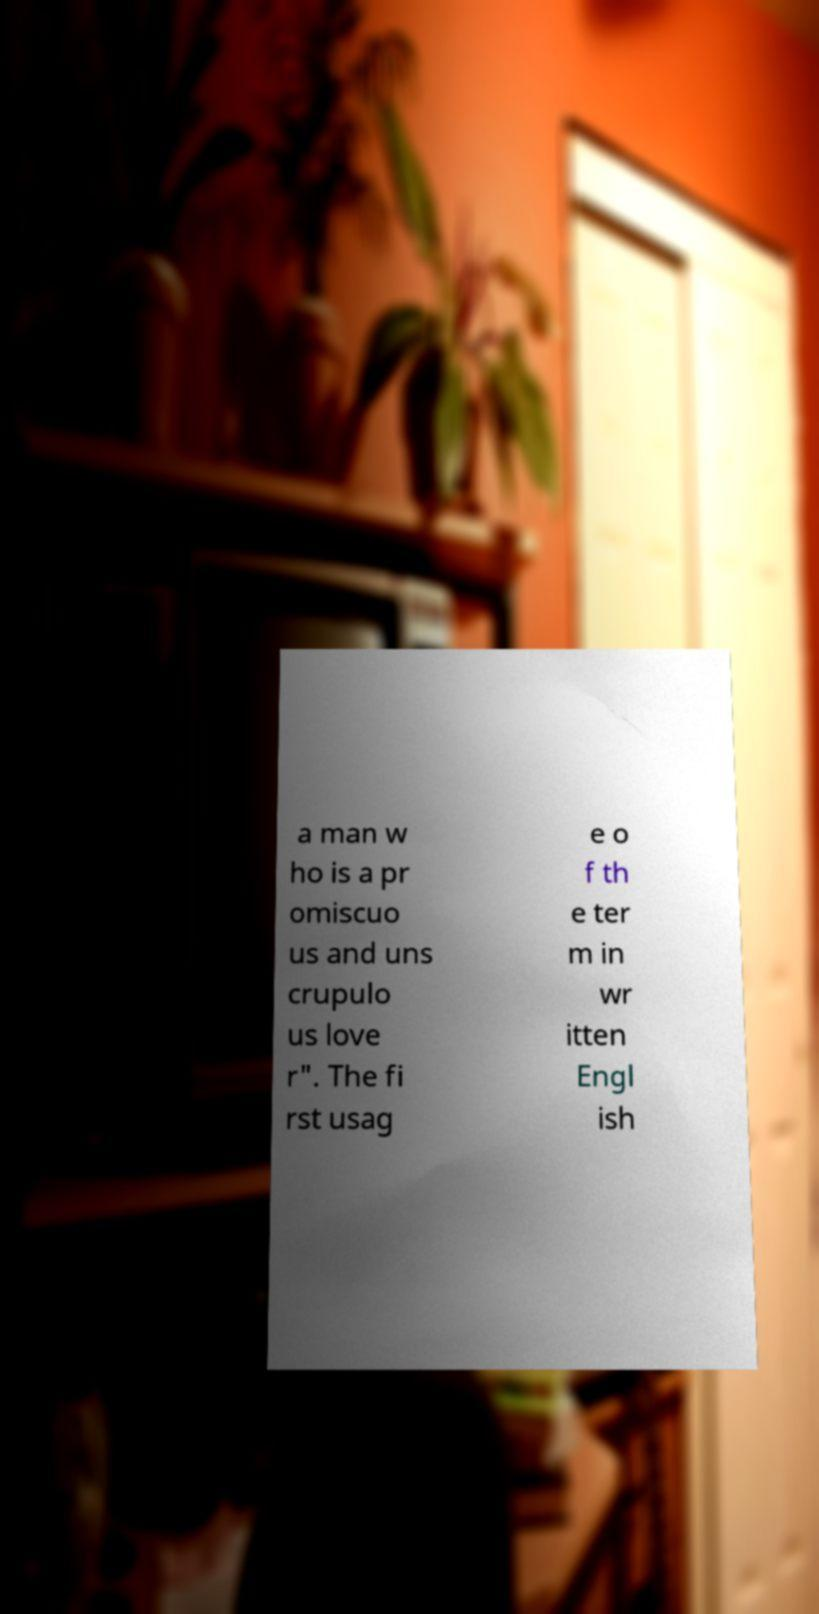For documentation purposes, I need the text within this image transcribed. Could you provide that? a man w ho is a pr omiscuo us and uns crupulo us love r". The fi rst usag e o f th e ter m in wr itten Engl ish 